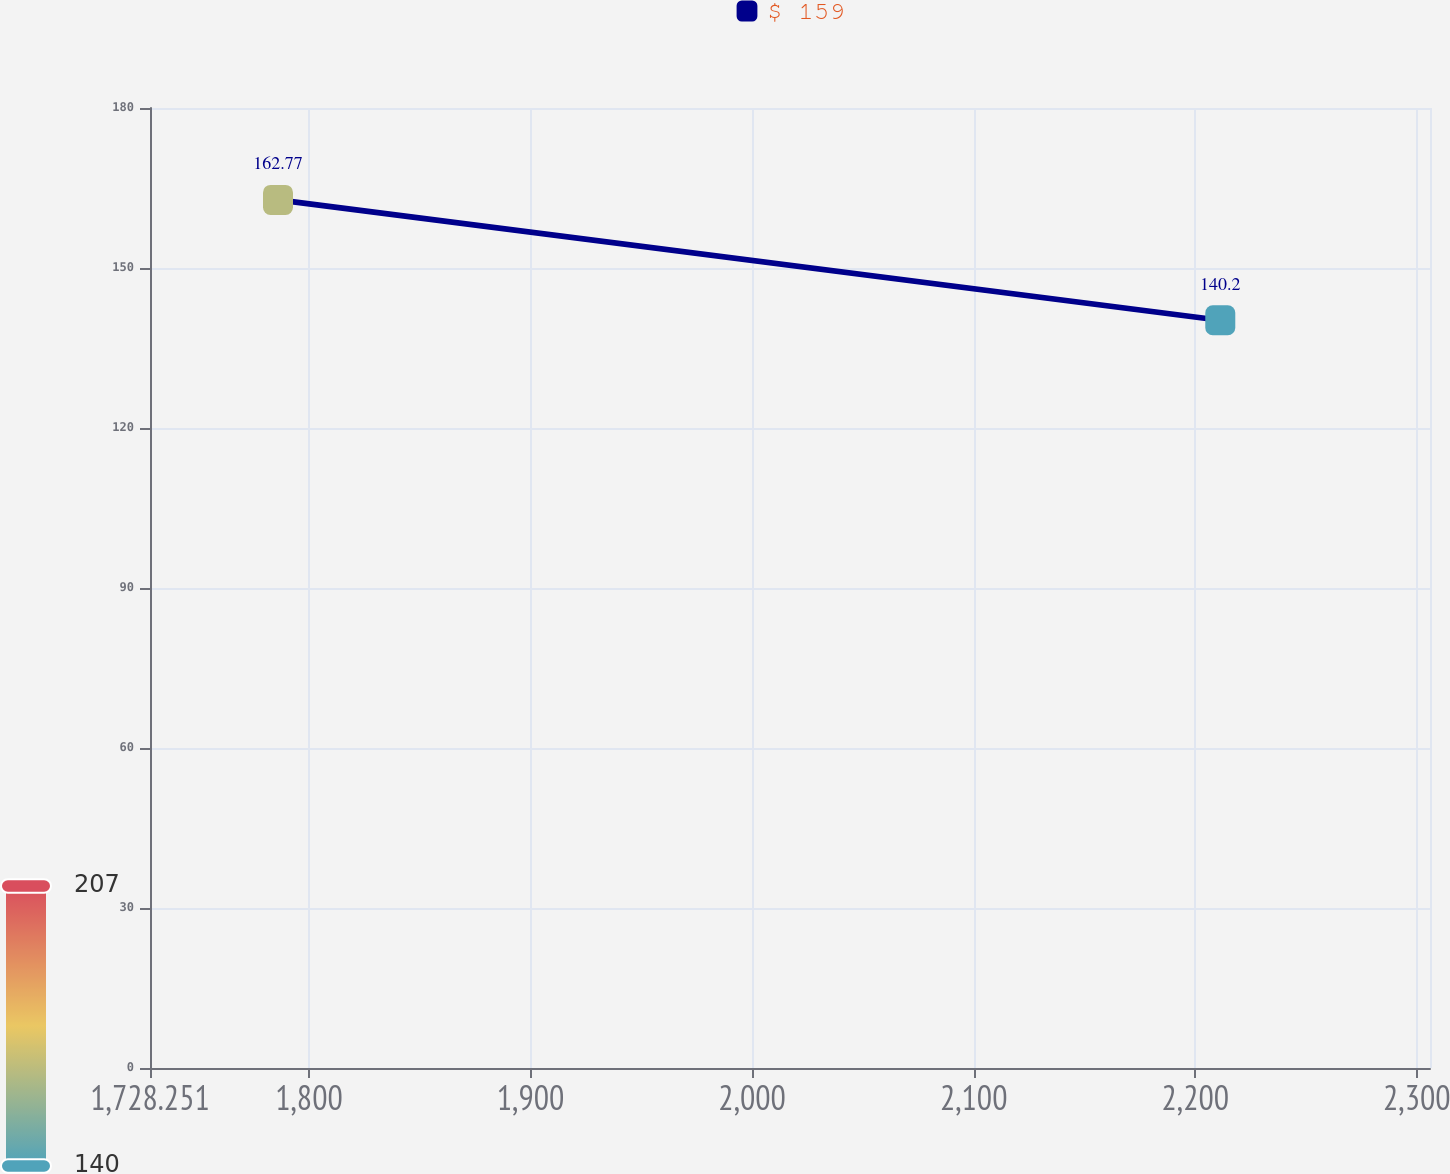Convert chart. <chart><loc_0><loc_0><loc_500><loc_500><line_chart><ecel><fcel>$ 159<nl><fcel>1786.02<fcel>162.77<nl><fcel>2211.29<fcel>140.2<nl><fcel>2311.02<fcel>200.87<nl><fcel>2363.71<fcel>207.34<nl></chart> 